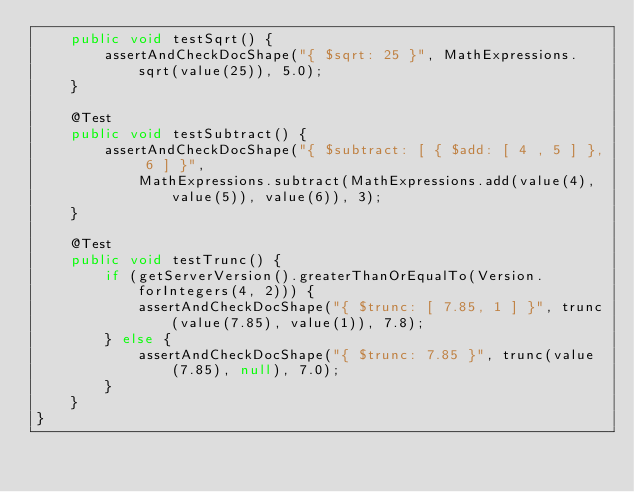<code> <loc_0><loc_0><loc_500><loc_500><_Java_>    public void testSqrt() {
        assertAndCheckDocShape("{ $sqrt: 25 }", MathExpressions.sqrt(value(25)), 5.0);
    }

    @Test
    public void testSubtract() {
        assertAndCheckDocShape("{ $subtract: [ { $add: [ 4 , 5 ] }, 6 ] }",
            MathExpressions.subtract(MathExpressions.add(value(4), value(5)), value(6)), 3);
    }

    @Test
    public void testTrunc() {
        if (getServerVersion().greaterThanOrEqualTo(Version.forIntegers(4, 2))) {
            assertAndCheckDocShape("{ $trunc: [ 7.85, 1 ] }", trunc(value(7.85), value(1)), 7.8);
        } else {
            assertAndCheckDocShape("{ $trunc: 7.85 }", trunc(value(7.85), null), 7.0);
        }
    }
}
</code> 